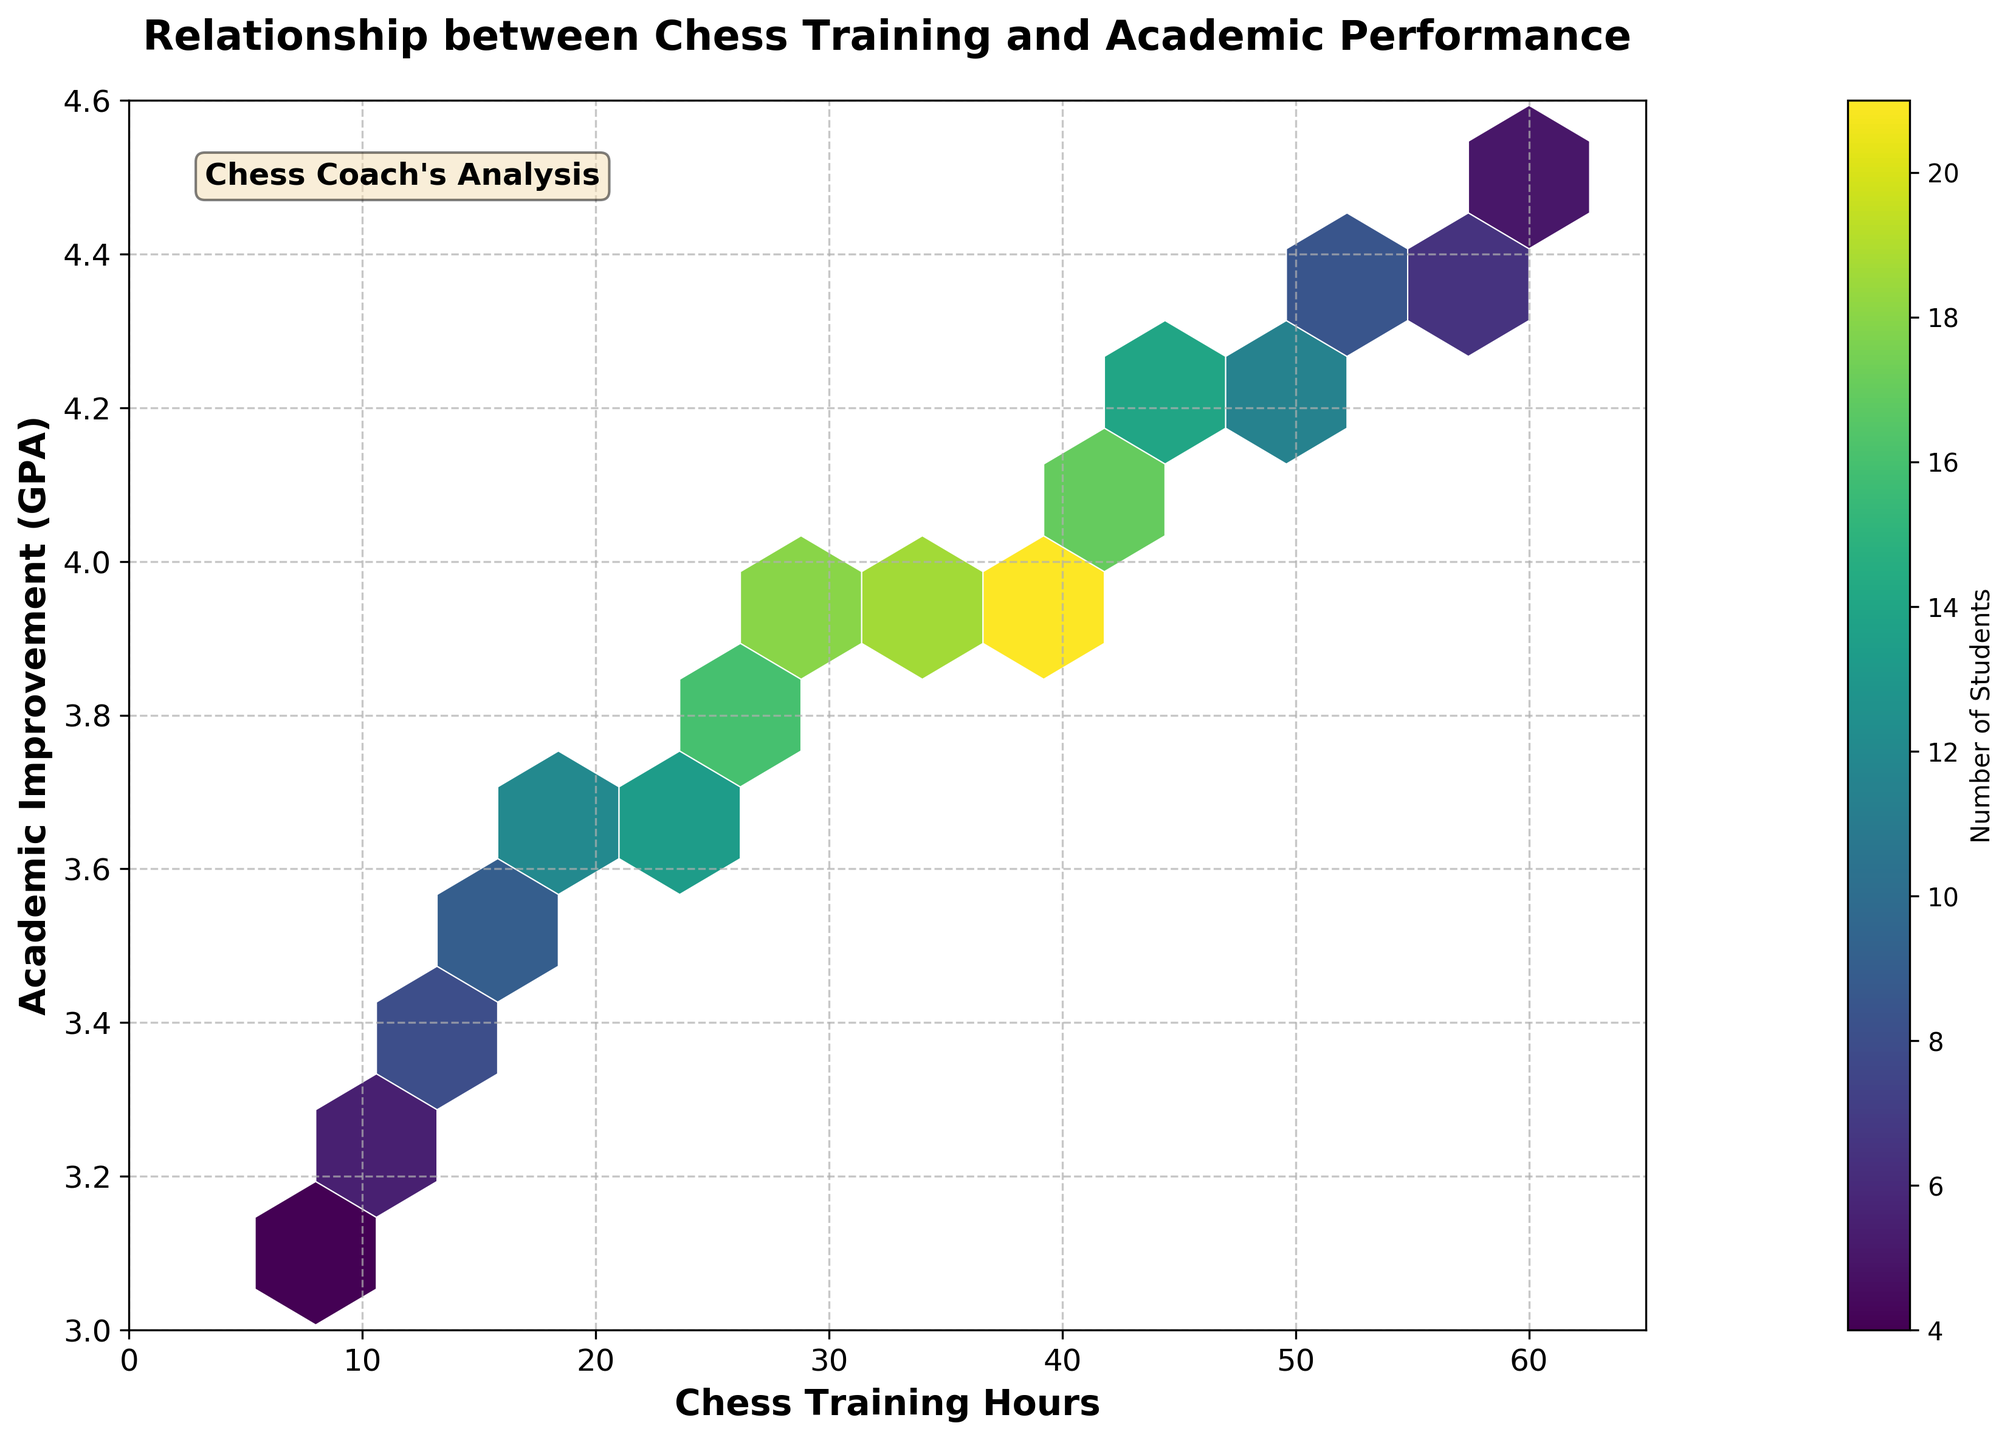What is the title of the plot? The title of the plot is often displayed prominently at the top. Here, it reads "Relationship between Chess Training and Academic Performance".
Answer: Relationship between Chess Training and Academic Performance What do the x-axis and y-axis represent? The x-axis label is "Chess Training Hours", and the y-axis label is "Academic Improvement (GPA)". These labels indicate the variables being plotted.
Answer: Chess Training Hours and Academic Improvement (GPA) Which color on the plot represents a higher number of students? In the plot, the color gradient shown in the color bar, going from lighter to darker shades, indicates increasing counts of students. The color bar shows that darker colors (like dark purple) represent higher numbers.
Answer: Darker colors What is the range of Chess Training Hours shown in the plot? The x-axis shows a range, and according to the labeled ticks, it spans from 0 to 65 hours.
Answer: 0 to 65 hours Where do you see the highest concentration of data points in terms of Chess Training Hours and GPA? Looking at the plot, the highest concentration of data points, shown by the darkest hexagons, is around 35 to 40 Chess Training Hours and a GPA of about 4.0.
Answer: 35 to 40 hours, 4.0 GPA What can be inferred about students who engage in 10 and 60 training hours respectively, in terms of their GPA? Observing the hexagons corresponding to these hours, students with 10 training hours have GPAs around 3.2, while those with 60 training hours have GPAs around 4.5. This suggests a positive relationship between training hours and GPA.
Answer: 3.2 GPA for 10 hours, 4.5 GPA for 60 hours How does the color bar help in interpreting the data represented in the hexagons? The color bar provides a scale for the number of students in each hexagon. By matching the hexagon color to the color bar, one can determine the count of students represented by that hexagon.
Answer: Matches hexagon color to student count Which range of Chess Training Hours has the most varied GPAs? By looking at the width of the hexbin plot on the y-axis, the range around 40 to 60 hours shows the most varied GPAs, spanning from approximately 3.4 to 4.5.
Answer: 40 to 60 hours Is there a general trend visible in the relationship between Chess Training Hours and Academic Improvement (GPA)? Observing the distribution and color intensity of the hexagons, there is a general upward trend suggesting that increased Chess Training Hours are associated with higher GPA.
Answer: Yes, upward trend How many students are represented by the hexagon with the darkest shade? Referring to the darkest color on the color bar, the count is matched to 21 students.
Answer: 21 students 